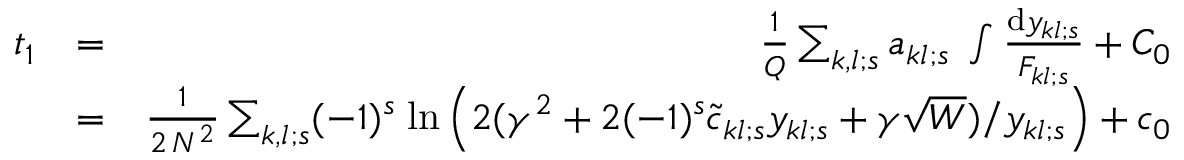Convert formula to latex. <formula><loc_0><loc_0><loc_500><loc_500>\begin{array} { r l r } { t _ { 1 } } & { = } & { { \frac { 1 } { Q } } \sum _ { k , l ; s } a _ { k l ; s } \, \int { \frac { d y _ { k l ; s } } { F _ { k l ; s } } } + C _ { 0 } } \\ & { = } & { { \frac { 1 } { 2 \, N ^ { 2 } } } \sum _ { k , l ; s } ( - 1 ) ^ { s } \, \ln \left ( 2 ( \gamma ^ { 2 } + 2 ( - 1 ) ^ { s } \tilde { c } _ { k l ; s } y _ { k l ; s } + \gamma \sqrt { W } ) / y _ { k l ; s } \right ) + c _ { 0 } } \end{array}</formula> 